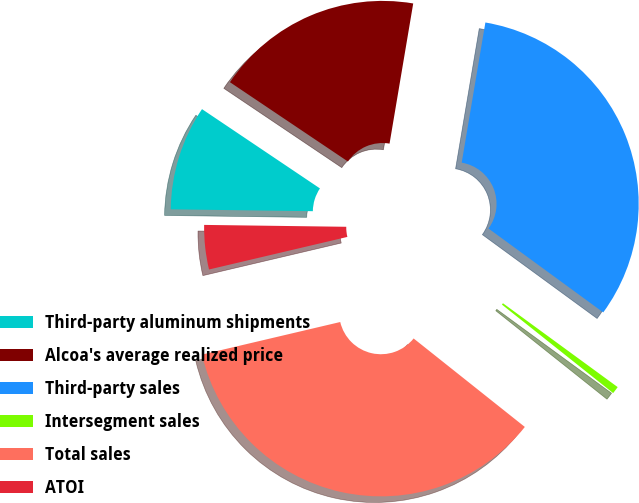<chart> <loc_0><loc_0><loc_500><loc_500><pie_chart><fcel>Third-party aluminum shipments<fcel>Alcoa's average realized price<fcel>Third-party sales<fcel>Intersegment sales<fcel>Total sales<fcel>ATOI<nl><fcel>9.21%<fcel>18.24%<fcel>32.38%<fcel>0.65%<fcel>35.62%<fcel>3.89%<nl></chart> 